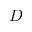Convert formula to latex. <formula><loc_0><loc_0><loc_500><loc_500>D</formula> 